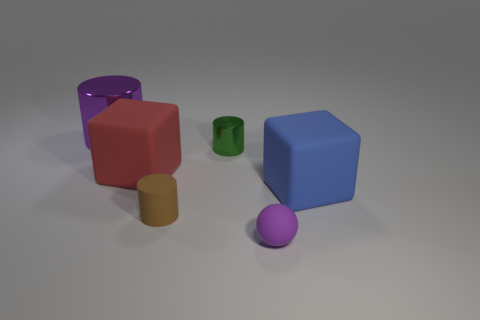Add 3 tiny brown rubber objects. How many objects exist? 9 Subtract all spheres. How many objects are left? 5 Add 1 big blue cubes. How many big blue cubes are left? 2 Add 6 red blocks. How many red blocks exist? 7 Subtract 0 yellow spheres. How many objects are left? 6 Subtract all large yellow rubber things. Subtract all large purple metallic cylinders. How many objects are left? 5 